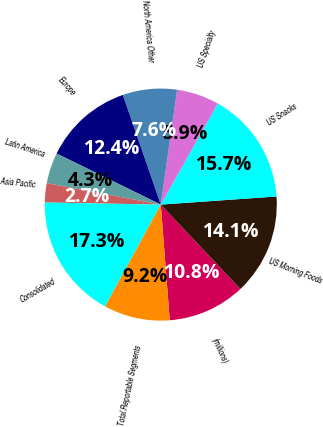Convert chart. <chart><loc_0><loc_0><loc_500><loc_500><pie_chart><fcel>(millions)<fcel>US Morning Foods<fcel>US Snacks<fcel>US Specialty<fcel>North America Other<fcel>Europe<fcel>Latin America<fcel>Asia Pacific<fcel>Consolidated<fcel>Total Reportable Segments<nl><fcel>10.81%<fcel>14.07%<fcel>15.7%<fcel>5.93%<fcel>7.56%<fcel>12.44%<fcel>4.3%<fcel>2.67%<fcel>17.33%<fcel>9.19%<nl></chart> 